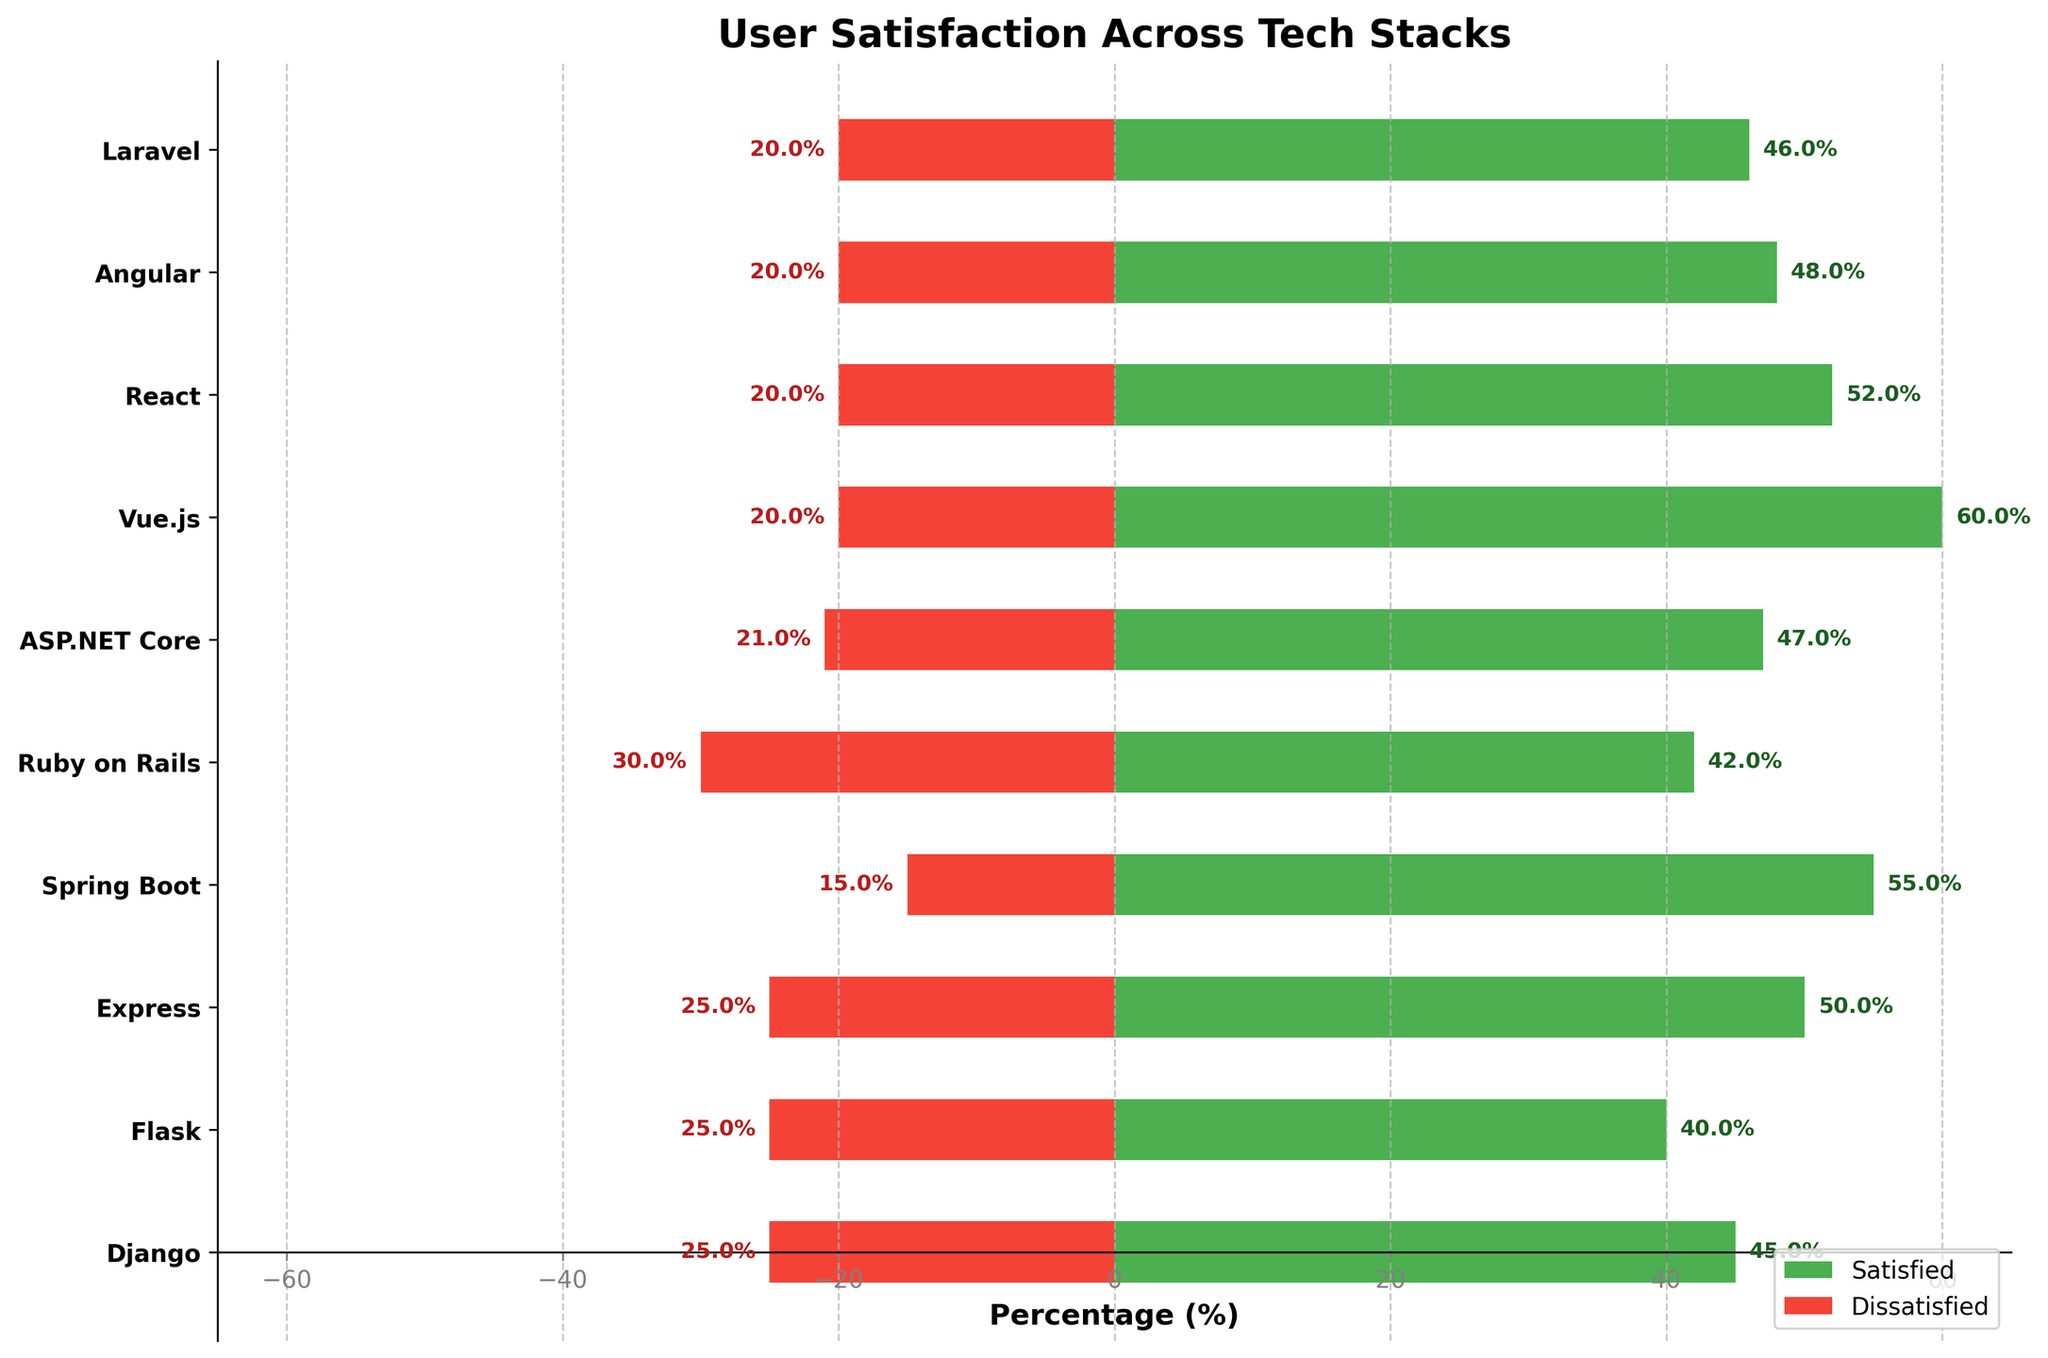Which tech stack has the highest percentage of satisfied users? From the figure, the bar representing Vue.js extends the furthest to the right in green, which indicates the highest percentage of satisfied users.
Answer: Vue.js Which tech stack has the highest percentage of dissatisfied users? By looking at the bars that extend to the left in red, Ruby on Rails has the longest bar, indicating the highest percentage of dissatisfied users.
Answer: Ruby on Rails What is the difference in the percentage of satisfied users between Spring Boot and Flask? From the figure, the percentages of satisfied users for Spring Boot and Flask are approximately 55% and 40%, respectively. The difference is 55% - 40%.
Answer: 15% Which tech stacks have a higher percentage of satisfied users compared to React? React has a satisfied user percentage of approximately 52%. From the figure, the tech stacks with satisfied user percentages greater than 52% are Spring Boot and Vue.js.
Answer: Spring Boot, Vue.js What is the range of the percentages of dissatisfied users across all tech stacks? The percentages of dissatisfied users range from around 15% (Spring Boot) to 30% (Ruby on Rails). The range is calculated as 30% - 15%.
Answer: 15% How much greater is the percentage of satisfied users for Django compared to the percentage of satisfied users for Laravel? The percentage of satisfied users for Django is around 45%, and for Laravel, it is approximately 46%.
Answer: -1% (Django has 1% lower) Which tech stack has the smallest percentage of neutral users? From the figure, Vue.js has the smallest percentage of neutral users since the bar in the middle for Vue.js is the shortest.
Answer: Vue.js What is the total percentage of both satisfied and dissatisfied users for ASP.NET Core? Adding the percentages of satisfied (around 47%) and dissatisfied (around 21%) users for ASP.NET Core gives the total percentage. 47% + 21% = 68%.
Answer: 68% How does the percentage of neutral users for Angular compare to the percentage of neutral users for Flask? The percentages of neutral users for Angular and Flask are approximately the same, both around 32% for Angular and 35% for Flask.
Answer: Flask is higher Which tech stacks have exactly 20% dissatisfied users? The tech stacks with bars extending exactly 20% to the left in red are Vue.js, React, Angular, and Laravel.
Answer: Vue.js, React, Angular, Laravel 